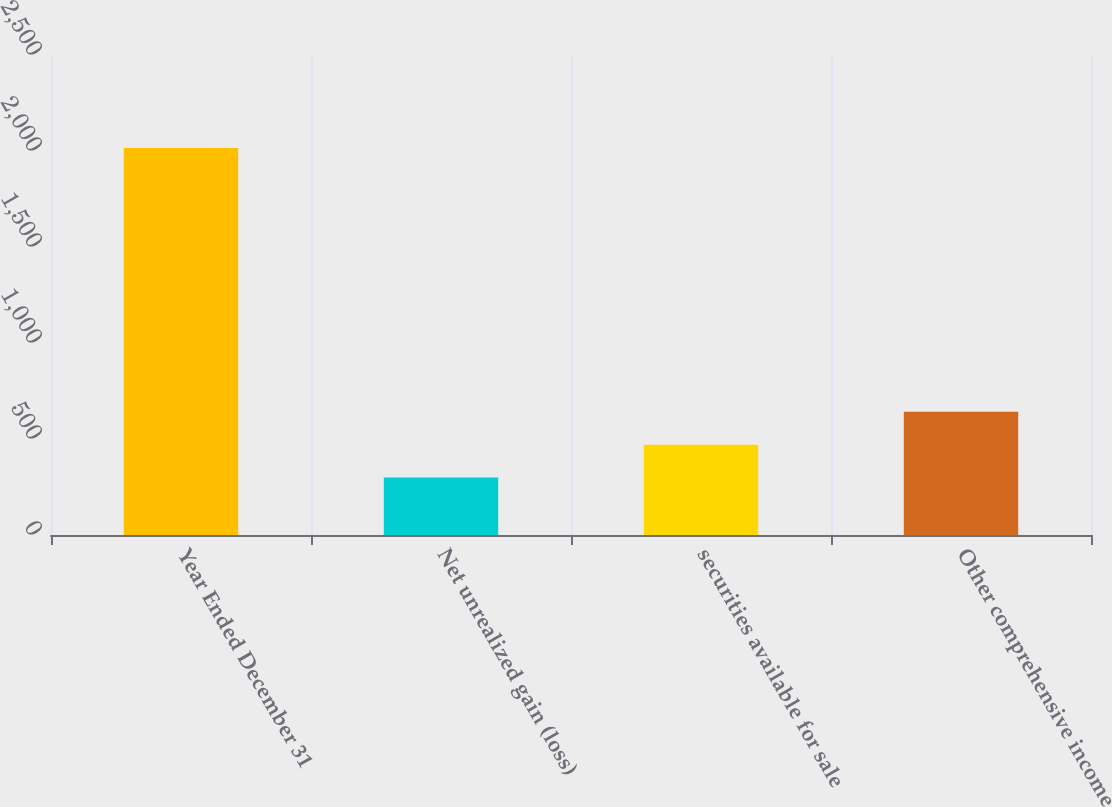Convert chart to OTSL. <chart><loc_0><loc_0><loc_500><loc_500><bar_chart><fcel>Year Ended December 31<fcel>Net unrealized gain (loss)<fcel>securities available for sale<fcel>Other comprehensive income<nl><fcel>2015<fcel>299<fcel>470.6<fcel>642.2<nl></chart> 